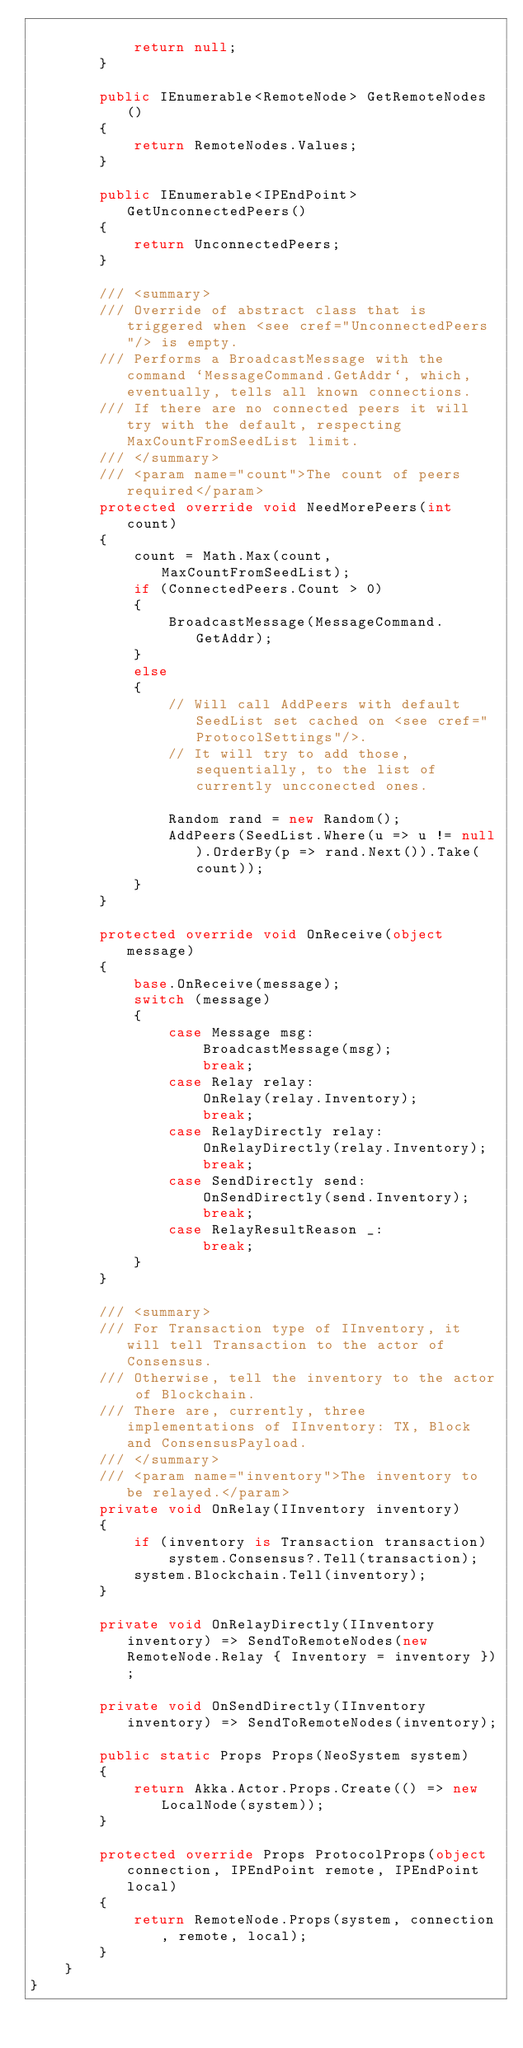<code> <loc_0><loc_0><loc_500><loc_500><_C#_>
            return null;
        }

        public IEnumerable<RemoteNode> GetRemoteNodes()
        {
            return RemoteNodes.Values;
        }

        public IEnumerable<IPEndPoint> GetUnconnectedPeers()
        {
            return UnconnectedPeers;
        }

        /// <summary>
        /// Override of abstract class that is triggered when <see cref="UnconnectedPeers"/> is empty.
        /// Performs a BroadcastMessage with the command `MessageCommand.GetAddr`, which, eventually, tells all known connections.
        /// If there are no connected peers it will try with the default, respecting MaxCountFromSeedList limit.
        /// </summary>
        /// <param name="count">The count of peers required</param>
        protected override void NeedMorePeers(int count)
        {
            count = Math.Max(count, MaxCountFromSeedList);
            if (ConnectedPeers.Count > 0)
            {
                BroadcastMessage(MessageCommand.GetAddr);
            }
            else
            {
                // Will call AddPeers with default SeedList set cached on <see cref="ProtocolSettings"/>.
                // It will try to add those, sequentially, to the list of currently uncconected ones.

                Random rand = new Random();
                AddPeers(SeedList.Where(u => u != null).OrderBy(p => rand.Next()).Take(count));
            }
        }

        protected override void OnReceive(object message)
        {
            base.OnReceive(message);
            switch (message)
            {
                case Message msg:
                    BroadcastMessage(msg);
                    break;
                case Relay relay:
                    OnRelay(relay.Inventory);
                    break;
                case RelayDirectly relay:
                    OnRelayDirectly(relay.Inventory);
                    break;
                case SendDirectly send:
                    OnSendDirectly(send.Inventory);
                    break;
                case RelayResultReason _:
                    break;
            }
        }

        /// <summary>
        /// For Transaction type of IInventory, it will tell Transaction to the actor of Consensus.
        /// Otherwise, tell the inventory to the actor of Blockchain.
        /// There are, currently, three implementations of IInventory: TX, Block and ConsensusPayload.
        /// </summary>
        /// <param name="inventory">The inventory to be relayed.</param>
        private void OnRelay(IInventory inventory)
        {
            if (inventory is Transaction transaction)
                system.Consensus?.Tell(transaction);
            system.Blockchain.Tell(inventory);
        }

        private void OnRelayDirectly(IInventory inventory) => SendToRemoteNodes(new RemoteNode.Relay { Inventory = inventory });

        private void OnSendDirectly(IInventory inventory) => SendToRemoteNodes(inventory);

        public static Props Props(NeoSystem system)
        {
            return Akka.Actor.Props.Create(() => new LocalNode(system));
        }

        protected override Props ProtocolProps(object connection, IPEndPoint remote, IPEndPoint local)
        {
            return RemoteNode.Props(system, connection, remote, local);
        }
    }
}
</code> 